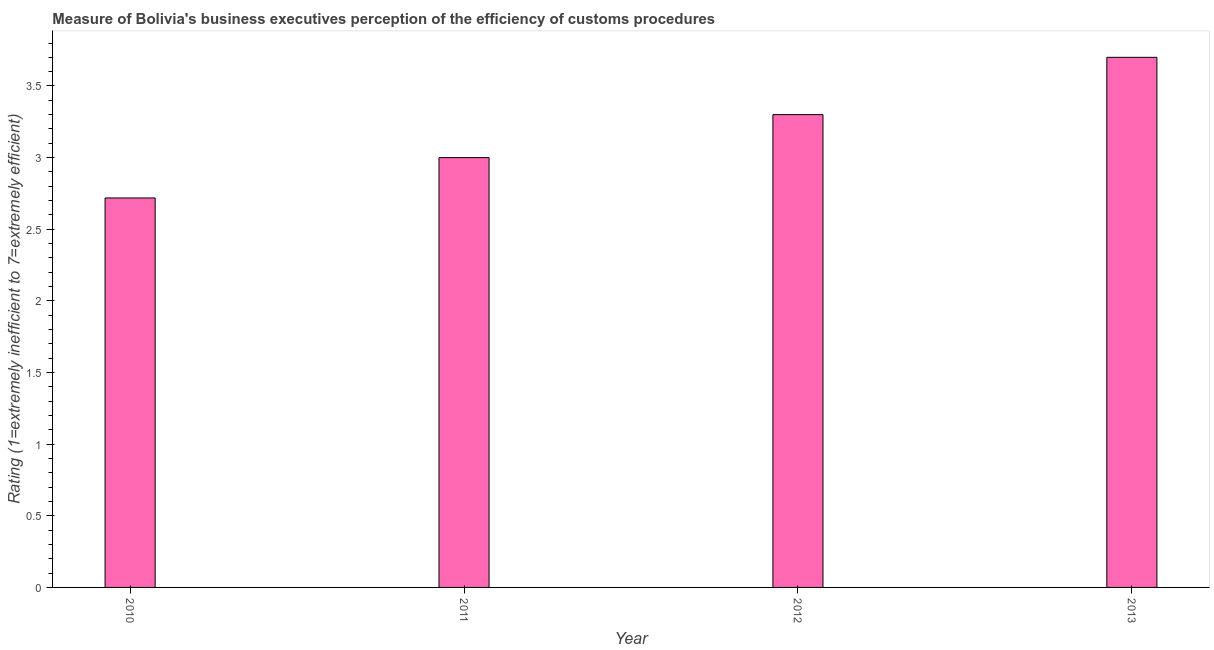Does the graph contain any zero values?
Offer a terse response. No. Does the graph contain grids?
Your response must be concise. No. What is the title of the graph?
Offer a very short reply. Measure of Bolivia's business executives perception of the efficiency of customs procedures. What is the label or title of the X-axis?
Make the answer very short. Year. What is the label or title of the Y-axis?
Offer a terse response. Rating (1=extremely inefficient to 7=extremely efficient). Across all years, what is the maximum rating measuring burden of customs procedure?
Your answer should be compact. 3.7. Across all years, what is the minimum rating measuring burden of customs procedure?
Provide a short and direct response. 2.72. In which year was the rating measuring burden of customs procedure maximum?
Provide a succinct answer. 2013. In which year was the rating measuring burden of customs procedure minimum?
Make the answer very short. 2010. What is the sum of the rating measuring burden of customs procedure?
Keep it short and to the point. 12.72. What is the average rating measuring burden of customs procedure per year?
Keep it short and to the point. 3.18. What is the median rating measuring burden of customs procedure?
Your answer should be very brief. 3.15. In how many years, is the rating measuring burden of customs procedure greater than 2.8 ?
Your answer should be very brief. 3. Do a majority of the years between 2013 and 2012 (inclusive) have rating measuring burden of customs procedure greater than 1.5 ?
Offer a terse response. No. What is the ratio of the rating measuring burden of customs procedure in 2012 to that in 2013?
Your answer should be compact. 0.89. What is the difference between the highest and the second highest rating measuring burden of customs procedure?
Keep it short and to the point. 0.4. How many bars are there?
Your answer should be very brief. 4. Are all the bars in the graph horizontal?
Your answer should be very brief. No. What is the difference between two consecutive major ticks on the Y-axis?
Give a very brief answer. 0.5. Are the values on the major ticks of Y-axis written in scientific E-notation?
Your answer should be compact. No. What is the Rating (1=extremely inefficient to 7=extremely efficient) in 2010?
Your answer should be compact. 2.72. What is the Rating (1=extremely inefficient to 7=extremely efficient) in 2013?
Your answer should be very brief. 3.7. What is the difference between the Rating (1=extremely inefficient to 7=extremely efficient) in 2010 and 2011?
Your answer should be compact. -0.28. What is the difference between the Rating (1=extremely inefficient to 7=extremely efficient) in 2010 and 2012?
Offer a terse response. -0.58. What is the difference between the Rating (1=extremely inefficient to 7=extremely efficient) in 2010 and 2013?
Your response must be concise. -0.98. What is the difference between the Rating (1=extremely inefficient to 7=extremely efficient) in 2011 and 2013?
Your answer should be compact. -0.7. What is the difference between the Rating (1=extremely inefficient to 7=extremely efficient) in 2012 and 2013?
Ensure brevity in your answer.  -0.4. What is the ratio of the Rating (1=extremely inefficient to 7=extremely efficient) in 2010 to that in 2011?
Your answer should be very brief. 0.91. What is the ratio of the Rating (1=extremely inefficient to 7=extremely efficient) in 2010 to that in 2012?
Ensure brevity in your answer.  0.82. What is the ratio of the Rating (1=extremely inefficient to 7=extremely efficient) in 2010 to that in 2013?
Your answer should be compact. 0.73. What is the ratio of the Rating (1=extremely inefficient to 7=extremely efficient) in 2011 to that in 2012?
Make the answer very short. 0.91. What is the ratio of the Rating (1=extremely inefficient to 7=extremely efficient) in 2011 to that in 2013?
Your answer should be very brief. 0.81. What is the ratio of the Rating (1=extremely inefficient to 7=extremely efficient) in 2012 to that in 2013?
Your response must be concise. 0.89. 